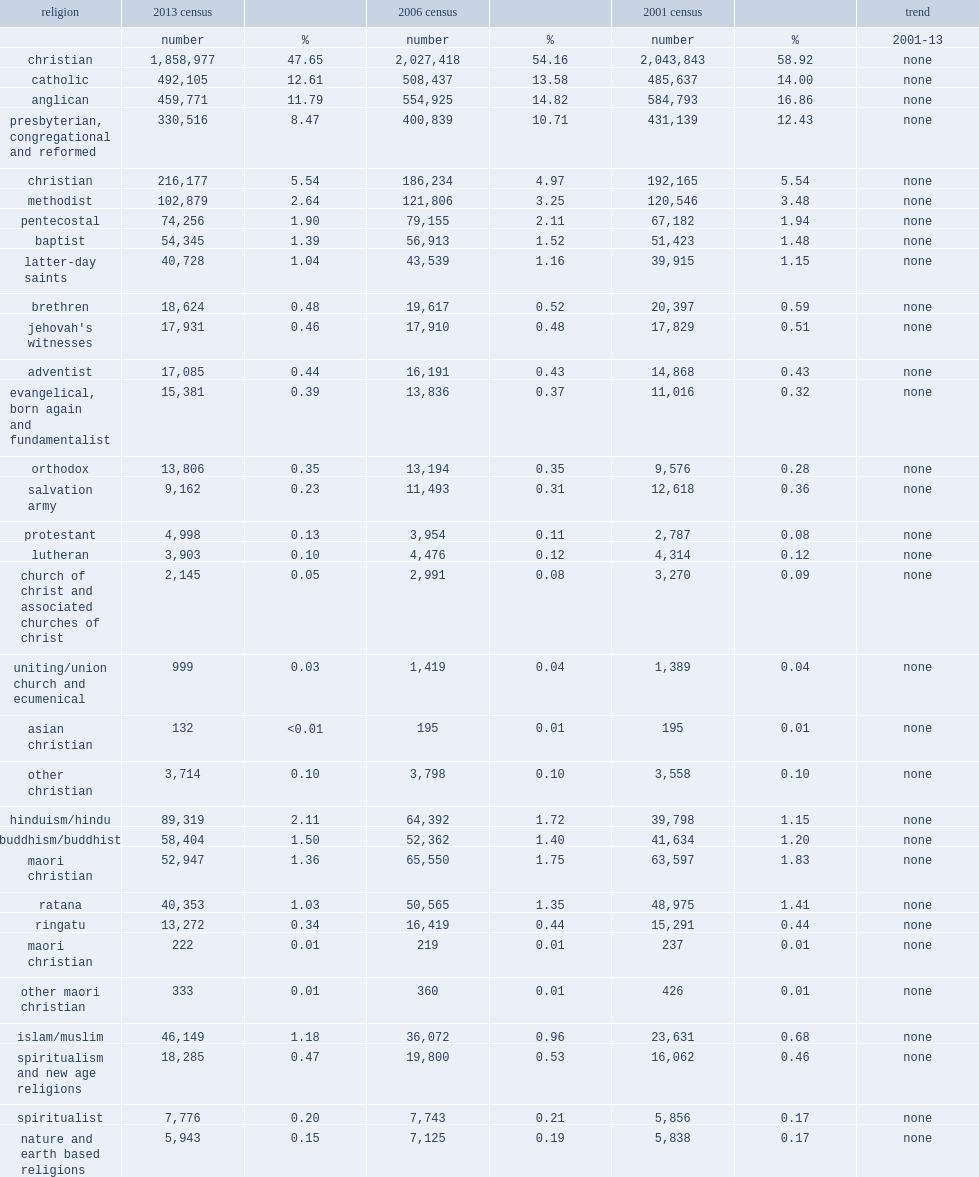What was the percentage that catholic religion decreased by? 12.61. 